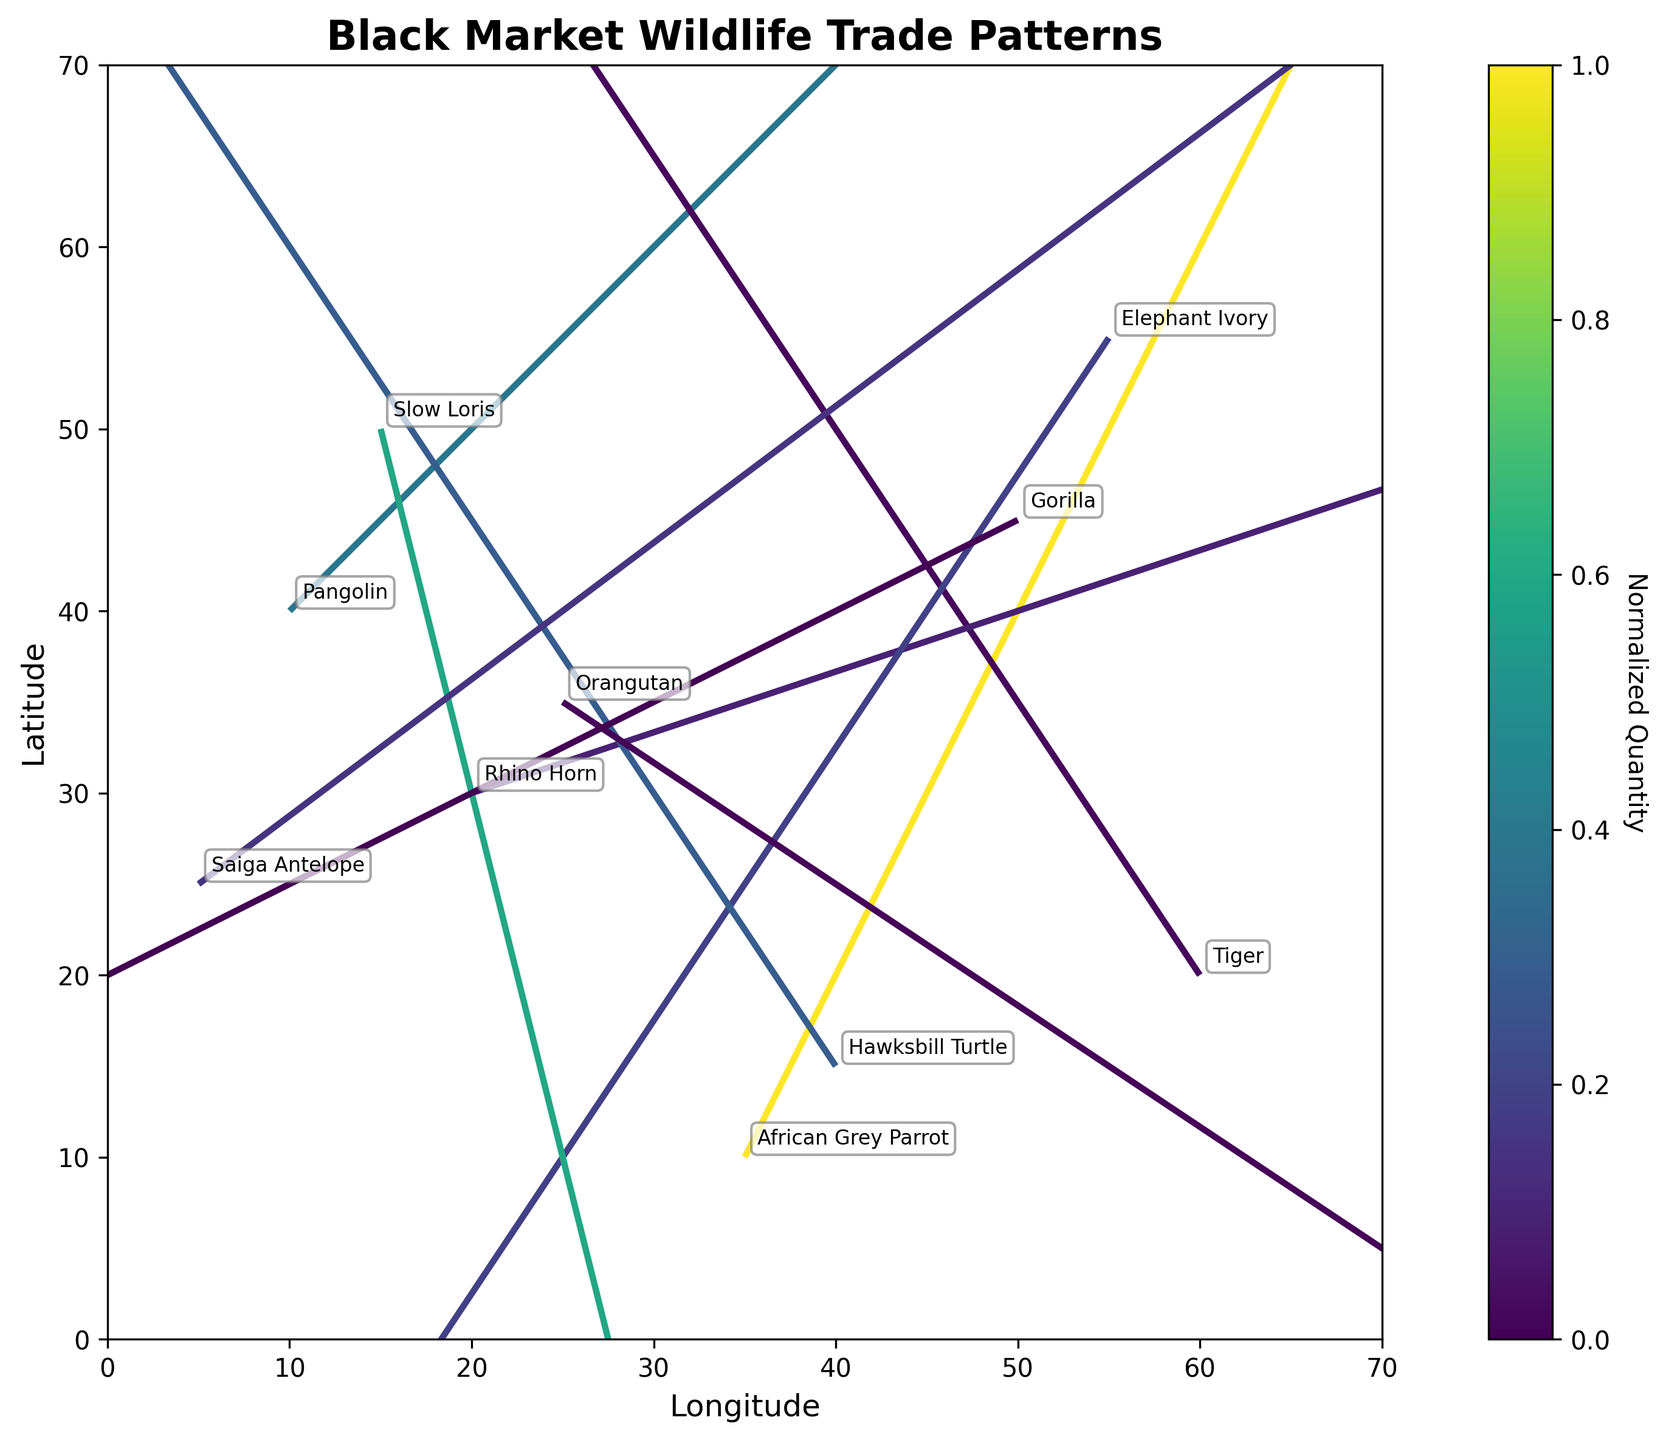What is the title of the plot? The title is located at the top central part of the plot. It gives an overview of what the plot represents.
Answer: Black Market Wildlife Trade Patterns What are the labels for the x and y axes? The x-axis label is typically placed below the horizontal axis, and the y-axis label is next to the vertical axis.
Answer: Longitude, Latitude How many arrow vectors are shown in the plot? Counting the number of arrow vectors visible in the plot will reveal this information.
Answer: 10 Which species is being moved the most in quantity? By examining the color intensity, which represents normalized quantity, the species with the highest color intensity is the answer.
Answer: African Grey Parrot Which species originates from the point (10, 40)? This species can be identified by looking at the annotated text at coordinates (10, 40) in the plot.
Answer: Pangolin What is the general direction of trade for the Elephant Ivory? Observe the arrow vector that starts from the origin point of Elephant Ivory and follow its direction towards the destination point.
Answer: From (55, 55) to (35, 25) Arrange the species in descending order of their quantity moved. By visually inspecting the color intensity of each arrow vector (normalized quantity), we can list the species from the most intense to the least intense.
Answer: African Grey Parrot, Slow Loris, Hawksbill Turtle, Saiga Antelope, Elephant Ivory, Rhino Horn, Pangolin, Tiger, Orangutan, Gorilla Are any species being moved between the same origin and destination coordinates? Check each set of coordinates for origin and destination to see if any pairs are identical.
Answer: No Which species has the shortest trade route? Identify the arrow vector with the smallest length by comparing the distances between origins and destinations. This involves calculating the Euclidean distances.
Answer: Gorilla What is the difference in quantity moved between the species with the highest and lowest quantities? Identify the species with the highest (African Grey Parrot with 500) and the lowest (Gorilla with 5) quantities, then subtract the lowest from the highest.
Answer: 495 